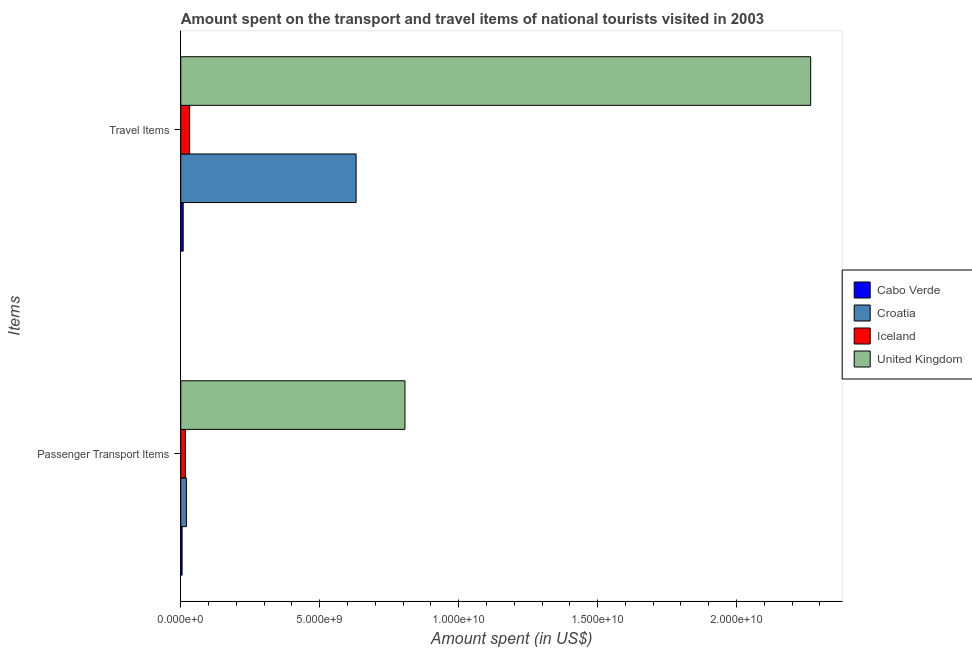How many bars are there on the 2nd tick from the bottom?
Ensure brevity in your answer.  4. What is the label of the 1st group of bars from the top?
Keep it short and to the point. Travel Items. What is the amount spent in travel items in Croatia?
Your response must be concise. 6.31e+09. Across all countries, what is the maximum amount spent in travel items?
Give a very brief answer. 2.27e+1. Across all countries, what is the minimum amount spent on passenger transport items?
Keep it short and to the point. 4.80e+07. In which country was the amount spent in travel items maximum?
Ensure brevity in your answer.  United Kingdom. In which country was the amount spent on passenger transport items minimum?
Give a very brief answer. Cabo Verde. What is the total amount spent on passenger transport items in the graph?
Your answer should be very brief. 8.49e+09. What is the difference between the amount spent on passenger transport items in Iceland and that in Croatia?
Give a very brief answer. -3.60e+07. What is the difference between the amount spent in travel items in Cabo Verde and the amount spent on passenger transport items in Iceland?
Your answer should be compact. -8.00e+07. What is the average amount spent on passenger transport items per country?
Offer a terse response. 2.12e+09. What is the difference between the amount spent in travel items and amount spent on passenger transport items in United Kingdom?
Your answer should be very brief. 1.46e+1. In how many countries, is the amount spent in travel items greater than 1000000000 US$?
Give a very brief answer. 2. What is the ratio of the amount spent in travel items in Croatia to that in United Kingdom?
Offer a terse response. 0.28. Is the amount spent in travel items in Cabo Verde less than that in Iceland?
Make the answer very short. Yes. In how many countries, is the amount spent in travel items greater than the average amount spent in travel items taken over all countries?
Your answer should be compact. 1. What does the 3rd bar from the top in Travel Items represents?
Your answer should be very brief. Croatia. What does the 1st bar from the bottom in Passenger Transport Items represents?
Provide a short and direct response. Cabo Verde. Are all the bars in the graph horizontal?
Your answer should be very brief. Yes. How many countries are there in the graph?
Your answer should be compact. 4. Does the graph contain any zero values?
Provide a short and direct response. No. Does the graph contain grids?
Give a very brief answer. No. What is the title of the graph?
Your response must be concise. Amount spent on the transport and travel items of national tourists visited in 2003. What is the label or title of the X-axis?
Your answer should be very brief. Amount spent (in US$). What is the label or title of the Y-axis?
Your response must be concise. Items. What is the Amount spent (in US$) in Cabo Verde in Passenger Transport Items?
Provide a short and direct response. 4.80e+07. What is the Amount spent (in US$) of Croatia in Passenger Transport Items?
Offer a very short reply. 2.03e+08. What is the Amount spent (in US$) of Iceland in Passenger Transport Items?
Your answer should be very brief. 1.67e+08. What is the Amount spent (in US$) of United Kingdom in Passenger Transport Items?
Make the answer very short. 8.07e+09. What is the Amount spent (in US$) of Cabo Verde in Travel Items?
Make the answer very short. 8.70e+07. What is the Amount spent (in US$) of Croatia in Travel Items?
Your answer should be very brief. 6.31e+09. What is the Amount spent (in US$) in Iceland in Travel Items?
Ensure brevity in your answer.  3.19e+08. What is the Amount spent (in US$) of United Kingdom in Travel Items?
Offer a very short reply. 2.27e+1. Across all Items, what is the maximum Amount spent (in US$) of Cabo Verde?
Keep it short and to the point. 8.70e+07. Across all Items, what is the maximum Amount spent (in US$) of Croatia?
Provide a succinct answer. 6.31e+09. Across all Items, what is the maximum Amount spent (in US$) in Iceland?
Keep it short and to the point. 3.19e+08. Across all Items, what is the maximum Amount spent (in US$) in United Kingdom?
Provide a succinct answer. 2.27e+1. Across all Items, what is the minimum Amount spent (in US$) in Cabo Verde?
Keep it short and to the point. 4.80e+07. Across all Items, what is the minimum Amount spent (in US$) of Croatia?
Ensure brevity in your answer.  2.03e+08. Across all Items, what is the minimum Amount spent (in US$) in Iceland?
Make the answer very short. 1.67e+08. Across all Items, what is the minimum Amount spent (in US$) in United Kingdom?
Your response must be concise. 8.07e+09. What is the total Amount spent (in US$) of Cabo Verde in the graph?
Give a very brief answer. 1.35e+08. What is the total Amount spent (in US$) of Croatia in the graph?
Keep it short and to the point. 6.51e+09. What is the total Amount spent (in US$) in Iceland in the graph?
Offer a very short reply. 4.86e+08. What is the total Amount spent (in US$) of United Kingdom in the graph?
Keep it short and to the point. 3.07e+1. What is the difference between the Amount spent (in US$) in Cabo Verde in Passenger Transport Items and that in Travel Items?
Give a very brief answer. -3.90e+07. What is the difference between the Amount spent (in US$) in Croatia in Passenger Transport Items and that in Travel Items?
Your answer should be very brief. -6.11e+09. What is the difference between the Amount spent (in US$) of Iceland in Passenger Transport Items and that in Travel Items?
Your answer should be very brief. -1.52e+08. What is the difference between the Amount spent (in US$) of United Kingdom in Passenger Transport Items and that in Travel Items?
Provide a short and direct response. -1.46e+1. What is the difference between the Amount spent (in US$) of Cabo Verde in Passenger Transport Items and the Amount spent (in US$) of Croatia in Travel Items?
Your response must be concise. -6.26e+09. What is the difference between the Amount spent (in US$) of Cabo Verde in Passenger Transport Items and the Amount spent (in US$) of Iceland in Travel Items?
Provide a succinct answer. -2.71e+08. What is the difference between the Amount spent (in US$) of Cabo Verde in Passenger Transport Items and the Amount spent (in US$) of United Kingdom in Travel Items?
Your answer should be very brief. -2.26e+1. What is the difference between the Amount spent (in US$) in Croatia in Passenger Transport Items and the Amount spent (in US$) in Iceland in Travel Items?
Give a very brief answer. -1.16e+08. What is the difference between the Amount spent (in US$) in Croatia in Passenger Transport Items and the Amount spent (in US$) in United Kingdom in Travel Items?
Keep it short and to the point. -2.25e+1. What is the difference between the Amount spent (in US$) of Iceland in Passenger Transport Items and the Amount spent (in US$) of United Kingdom in Travel Items?
Provide a short and direct response. -2.25e+1. What is the average Amount spent (in US$) in Cabo Verde per Items?
Provide a succinct answer. 6.75e+07. What is the average Amount spent (in US$) in Croatia per Items?
Provide a succinct answer. 3.26e+09. What is the average Amount spent (in US$) in Iceland per Items?
Ensure brevity in your answer.  2.43e+08. What is the average Amount spent (in US$) in United Kingdom per Items?
Offer a very short reply. 1.54e+1. What is the difference between the Amount spent (in US$) in Cabo Verde and Amount spent (in US$) in Croatia in Passenger Transport Items?
Your answer should be compact. -1.55e+08. What is the difference between the Amount spent (in US$) in Cabo Verde and Amount spent (in US$) in Iceland in Passenger Transport Items?
Your answer should be very brief. -1.19e+08. What is the difference between the Amount spent (in US$) of Cabo Verde and Amount spent (in US$) of United Kingdom in Passenger Transport Items?
Your answer should be very brief. -8.02e+09. What is the difference between the Amount spent (in US$) of Croatia and Amount spent (in US$) of Iceland in Passenger Transport Items?
Your answer should be compact. 3.60e+07. What is the difference between the Amount spent (in US$) in Croatia and Amount spent (in US$) in United Kingdom in Passenger Transport Items?
Keep it short and to the point. -7.86e+09. What is the difference between the Amount spent (in US$) in Iceland and Amount spent (in US$) in United Kingdom in Passenger Transport Items?
Give a very brief answer. -7.90e+09. What is the difference between the Amount spent (in US$) of Cabo Verde and Amount spent (in US$) of Croatia in Travel Items?
Your answer should be compact. -6.22e+09. What is the difference between the Amount spent (in US$) in Cabo Verde and Amount spent (in US$) in Iceland in Travel Items?
Provide a succinct answer. -2.32e+08. What is the difference between the Amount spent (in US$) in Cabo Verde and Amount spent (in US$) in United Kingdom in Travel Items?
Offer a terse response. -2.26e+1. What is the difference between the Amount spent (in US$) in Croatia and Amount spent (in US$) in Iceland in Travel Items?
Your answer should be very brief. 5.99e+09. What is the difference between the Amount spent (in US$) in Croatia and Amount spent (in US$) in United Kingdom in Travel Items?
Offer a terse response. -1.64e+1. What is the difference between the Amount spent (in US$) of Iceland and Amount spent (in US$) of United Kingdom in Travel Items?
Your answer should be very brief. -2.23e+1. What is the ratio of the Amount spent (in US$) in Cabo Verde in Passenger Transport Items to that in Travel Items?
Offer a very short reply. 0.55. What is the ratio of the Amount spent (in US$) of Croatia in Passenger Transport Items to that in Travel Items?
Provide a short and direct response. 0.03. What is the ratio of the Amount spent (in US$) in Iceland in Passenger Transport Items to that in Travel Items?
Offer a very short reply. 0.52. What is the ratio of the Amount spent (in US$) in United Kingdom in Passenger Transport Items to that in Travel Items?
Provide a short and direct response. 0.36. What is the difference between the highest and the second highest Amount spent (in US$) in Cabo Verde?
Give a very brief answer. 3.90e+07. What is the difference between the highest and the second highest Amount spent (in US$) in Croatia?
Offer a very short reply. 6.11e+09. What is the difference between the highest and the second highest Amount spent (in US$) of Iceland?
Keep it short and to the point. 1.52e+08. What is the difference between the highest and the second highest Amount spent (in US$) in United Kingdom?
Provide a short and direct response. 1.46e+1. What is the difference between the highest and the lowest Amount spent (in US$) of Cabo Verde?
Provide a short and direct response. 3.90e+07. What is the difference between the highest and the lowest Amount spent (in US$) of Croatia?
Offer a terse response. 6.11e+09. What is the difference between the highest and the lowest Amount spent (in US$) in Iceland?
Provide a succinct answer. 1.52e+08. What is the difference between the highest and the lowest Amount spent (in US$) in United Kingdom?
Your response must be concise. 1.46e+1. 